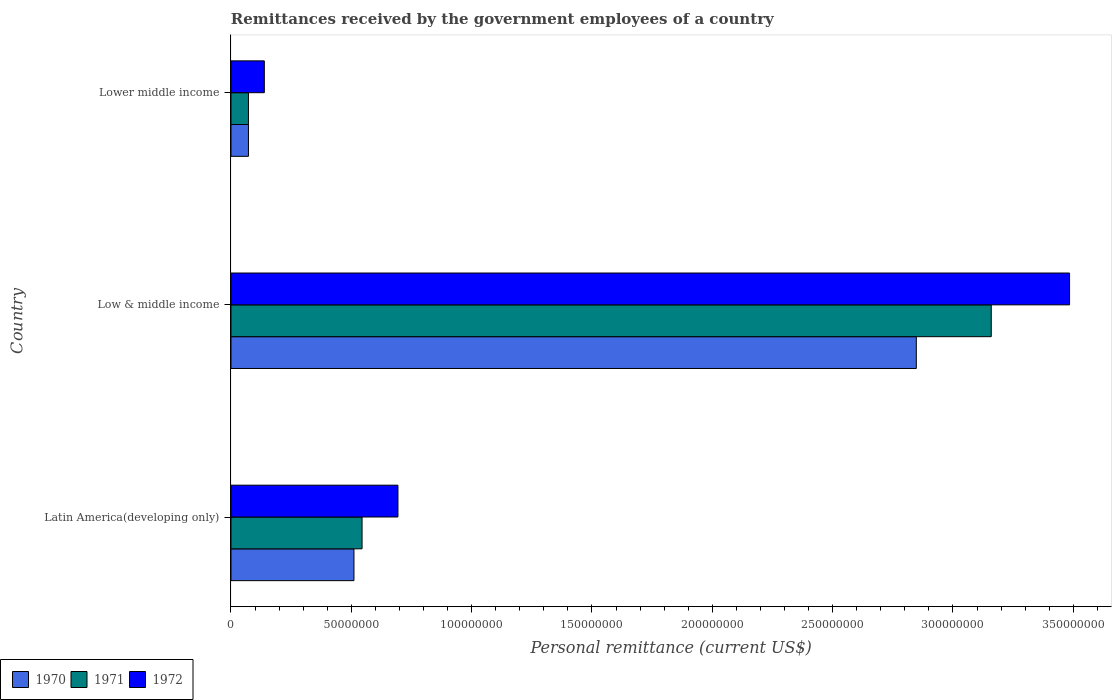How many groups of bars are there?
Ensure brevity in your answer.  3. How many bars are there on the 1st tick from the top?
Give a very brief answer. 3. How many bars are there on the 1st tick from the bottom?
Ensure brevity in your answer.  3. What is the label of the 2nd group of bars from the top?
Your response must be concise. Low & middle income. In how many cases, is the number of bars for a given country not equal to the number of legend labels?
Provide a succinct answer. 0. What is the remittances received by the government employees in 1972 in Lower middle income?
Your answer should be compact. 1.39e+07. Across all countries, what is the maximum remittances received by the government employees in 1972?
Your response must be concise. 3.48e+08. Across all countries, what is the minimum remittances received by the government employees in 1972?
Provide a short and direct response. 1.39e+07. In which country was the remittances received by the government employees in 1970 minimum?
Provide a succinct answer. Lower middle income. What is the total remittances received by the government employees in 1970 in the graph?
Keep it short and to the point. 3.43e+08. What is the difference between the remittances received by the government employees in 1970 in Low & middle income and that in Lower middle income?
Provide a succinct answer. 2.77e+08. What is the difference between the remittances received by the government employees in 1971 in Lower middle income and the remittances received by the government employees in 1970 in Latin America(developing only)?
Your answer should be compact. -4.38e+07. What is the average remittances received by the government employees in 1972 per country?
Your answer should be very brief. 1.44e+08. What is the difference between the remittances received by the government employees in 1971 and remittances received by the government employees in 1972 in Low & middle income?
Ensure brevity in your answer.  -3.25e+07. What is the ratio of the remittances received by the government employees in 1970 in Latin America(developing only) to that in Low & middle income?
Make the answer very short. 0.18. Is the remittances received by the government employees in 1972 in Low & middle income less than that in Lower middle income?
Make the answer very short. No. Is the difference between the remittances received by the government employees in 1971 in Latin America(developing only) and Low & middle income greater than the difference between the remittances received by the government employees in 1972 in Latin America(developing only) and Low & middle income?
Give a very brief answer. Yes. What is the difference between the highest and the second highest remittances received by the government employees in 1970?
Offer a terse response. 2.34e+08. What is the difference between the highest and the lowest remittances received by the government employees in 1970?
Your answer should be compact. 2.77e+08. In how many countries, is the remittances received by the government employees in 1972 greater than the average remittances received by the government employees in 1972 taken over all countries?
Your answer should be very brief. 1. What does the 1st bar from the bottom in Low & middle income represents?
Offer a very short reply. 1970. How many bars are there?
Your response must be concise. 9. Are all the bars in the graph horizontal?
Offer a very short reply. Yes. What is the difference between two consecutive major ticks on the X-axis?
Make the answer very short. 5.00e+07. Are the values on the major ticks of X-axis written in scientific E-notation?
Offer a very short reply. No. How many legend labels are there?
Offer a very short reply. 3. What is the title of the graph?
Provide a succinct answer. Remittances received by the government employees of a country. What is the label or title of the X-axis?
Offer a very short reply. Personal remittance (current US$). What is the Personal remittance (current US$) in 1970 in Latin America(developing only)?
Your response must be concise. 5.11e+07. What is the Personal remittance (current US$) of 1971 in Latin America(developing only)?
Your answer should be very brief. 5.45e+07. What is the Personal remittance (current US$) in 1972 in Latin America(developing only)?
Your answer should be compact. 6.94e+07. What is the Personal remittance (current US$) in 1970 in Low & middle income?
Your answer should be compact. 2.85e+08. What is the Personal remittance (current US$) in 1971 in Low & middle income?
Your answer should be compact. 3.16e+08. What is the Personal remittance (current US$) in 1972 in Low & middle income?
Give a very brief answer. 3.48e+08. What is the Personal remittance (current US$) in 1970 in Lower middle income?
Offer a terse response. 7.26e+06. What is the Personal remittance (current US$) in 1971 in Lower middle income?
Provide a short and direct response. 7.26e+06. What is the Personal remittance (current US$) in 1972 in Lower middle income?
Your answer should be compact. 1.39e+07. Across all countries, what is the maximum Personal remittance (current US$) in 1970?
Keep it short and to the point. 2.85e+08. Across all countries, what is the maximum Personal remittance (current US$) of 1971?
Provide a short and direct response. 3.16e+08. Across all countries, what is the maximum Personal remittance (current US$) in 1972?
Your answer should be very brief. 3.48e+08. Across all countries, what is the minimum Personal remittance (current US$) in 1970?
Keep it short and to the point. 7.26e+06. Across all countries, what is the minimum Personal remittance (current US$) in 1971?
Provide a short and direct response. 7.26e+06. Across all countries, what is the minimum Personal remittance (current US$) in 1972?
Offer a terse response. 1.39e+07. What is the total Personal remittance (current US$) of 1970 in the graph?
Your answer should be very brief. 3.43e+08. What is the total Personal remittance (current US$) in 1971 in the graph?
Your answer should be compact. 3.78e+08. What is the total Personal remittance (current US$) in 1972 in the graph?
Keep it short and to the point. 4.32e+08. What is the difference between the Personal remittance (current US$) in 1970 in Latin America(developing only) and that in Low & middle income?
Keep it short and to the point. -2.34e+08. What is the difference between the Personal remittance (current US$) in 1971 in Latin America(developing only) and that in Low & middle income?
Make the answer very short. -2.61e+08. What is the difference between the Personal remittance (current US$) in 1972 in Latin America(developing only) and that in Low & middle income?
Offer a terse response. -2.79e+08. What is the difference between the Personal remittance (current US$) in 1970 in Latin America(developing only) and that in Lower middle income?
Your response must be concise. 4.38e+07. What is the difference between the Personal remittance (current US$) of 1971 in Latin America(developing only) and that in Lower middle income?
Provide a succinct answer. 4.72e+07. What is the difference between the Personal remittance (current US$) of 1972 in Latin America(developing only) and that in Lower middle income?
Keep it short and to the point. 5.55e+07. What is the difference between the Personal remittance (current US$) in 1970 in Low & middle income and that in Lower middle income?
Provide a succinct answer. 2.77e+08. What is the difference between the Personal remittance (current US$) of 1971 in Low & middle income and that in Lower middle income?
Offer a very short reply. 3.09e+08. What is the difference between the Personal remittance (current US$) of 1972 in Low & middle income and that in Lower middle income?
Make the answer very short. 3.35e+08. What is the difference between the Personal remittance (current US$) in 1970 in Latin America(developing only) and the Personal remittance (current US$) in 1971 in Low & middle income?
Offer a very short reply. -2.65e+08. What is the difference between the Personal remittance (current US$) in 1970 in Latin America(developing only) and the Personal remittance (current US$) in 1972 in Low & middle income?
Offer a very short reply. -2.97e+08. What is the difference between the Personal remittance (current US$) of 1971 in Latin America(developing only) and the Personal remittance (current US$) of 1972 in Low & middle income?
Offer a terse response. -2.94e+08. What is the difference between the Personal remittance (current US$) of 1970 in Latin America(developing only) and the Personal remittance (current US$) of 1971 in Lower middle income?
Provide a succinct answer. 4.38e+07. What is the difference between the Personal remittance (current US$) of 1970 in Latin America(developing only) and the Personal remittance (current US$) of 1972 in Lower middle income?
Your response must be concise. 3.72e+07. What is the difference between the Personal remittance (current US$) of 1971 in Latin America(developing only) and the Personal remittance (current US$) of 1972 in Lower middle income?
Provide a short and direct response. 4.06e+07. What is the difference between the Personal remittance (current US$) of 1970 in Low & middle income and the Personal remittance (current US$) of 1971 in Lower middle income?
Offer a terse response. 2.77e+08. What is the difference between the Personal remittance (current US$) in 1970 in Low & middle income and the Personal remittance (current US$) in 1972 in Lower middle income?
Offer a terse response. 2.71e+08. What is the difference between the Personal remittance (current US$) of 1971 in Low & middle income and the Personal remittance (current US$) of 1972 in Lower middle income?
Keep it short and to the point. 3.02e+08. What is the average Personal remittance (current US$) in 1970 per country?
Your response must be concise. 1.14e+08. What is the average Personal remittance (current US$) of 1971 per country?
Offer a terse response. 1.26e+08. What is the average Personal remittance (current US$) in 1972 per country?
Your answer should be very brief. 1.44e+08. What is the difference between the Personal remittance (current US$) of 1970 and Personal remittance (current US$) of 1971 in Latin America(developing only)?
Your response must be concise. -3.37e+06. What is the difference between the Personal remittance (current US$) in 1970 and Personal remittance (current US$) in 1972 in Latin America(developing only)?
Offer a very short reply. -1.83e+07. What is the difference between the Personal remittance (current US$) of 1971 and Personal remittance (current US$) of 1972 in Latin America(developing only)?
Keep it short and to the point. -1.49e+07. What is the difference between the Personal remittance (current US$) in 1970 and Personal remittance (current US$) in 1971 in Low & middle income?
Ensure brevity in your answer.  -3.11e+07. What is the difference between the Personal remittance (current US$) in 1970 and Personal remittance (current US$) in 1972 in Low & middle income?
Offer a very short reply. -6.37e+07. What is the difference between the Personal remittance (current US$) in 1971 and Personal remittance (current US$) in 1972 in Low & middle income?
Your response must be concise. -3.25e+07. What is the difference between the Personal remittance (current US$) in 1970 and Personal remittance (current US$) in 1971 in Lower middle income?
Ensure brevity in your answer.  0. What is the difference between the Personal remittance (current US$) in 1970 and Personal remittance (current US$) in 1972 in Lower middle income?
Give a very brief answer. -6.60e+06. What is the difference between the Personal remittance (current US$) in 1971 and Personal remittance (current US$) in 1972 in Lower middle income?
Your answer should be compact. -6.60e+06. What is the ratio of the Personal remittance (current US$) in 1970 in Latin America(developing only) to that in Low & middle income?
Your answer should be compact. 0.18. What is the ratio of the Personal remittance (current US$) in 1971 in Latin America(developing only) to that in Low & middle income?
Your response must be concise. 0.17. What is the ratio of the Personal remittance (current US$) of 1972 in Latin America(developing only) to that in Low & middle income?
Offer a very short reply. 0.2. What is the ratio of the Personal remittance (current US$) of 1970 in Latin America(developing only) to that in Lower middle income?
Your answer should be very brief. 7.04. What is the ratio of the Personal remittance (current US$) of 1971 in Latin America(developing only) to that in Lower middle income?
Make the answer very short. 7.5. What is the ratio of the Personal remittance (current US$) in 1972 in Latin America(developing only) to that in Lower middle income?
Provide a short and direct response. 5.01. What is the ratio of the Personal remittance (current US$) of 1970 in Low & middle income to that in Lower middle income?
Provide a short and direct response. 39.22. What is the ratio of the Personal remittance (current US$) in 1971 in Low & middle income to that in Lower middle income?
Keep it short and to the point. 43.51. What is the ratio of the Personal remittance (current US$) in 1972 in Low & middle income to that in Lower middle income?
Keep it short and to the point. 25.14. What is the difference between the highest and the second highest Personal remittance (current US$) in 1970?
Your answer should be very brief. 2.34e+08. What is the difference between the highest and the second highest Personal remittance (current US$) in 1971?
Your answer should be very brief. 2.61e+08. What is the difference between the highest and the second highest Personal remittance (current US$) in 1972?
Offer a very short reply. 2.79e+08. What is the difference between the highest and the lowest Personal remittance (current US$) in 1970?
Provide a short and direct response. 2.77e+08. What is the difference between the highest and the lowest Personal remittance (current US$) in 1971?
Your response must be concise. 3.09e+08. What is the difference between the highest and the lowest Personal remittance (current US$) of 1972?
Your answer should be very brief. 3.35e+08. 